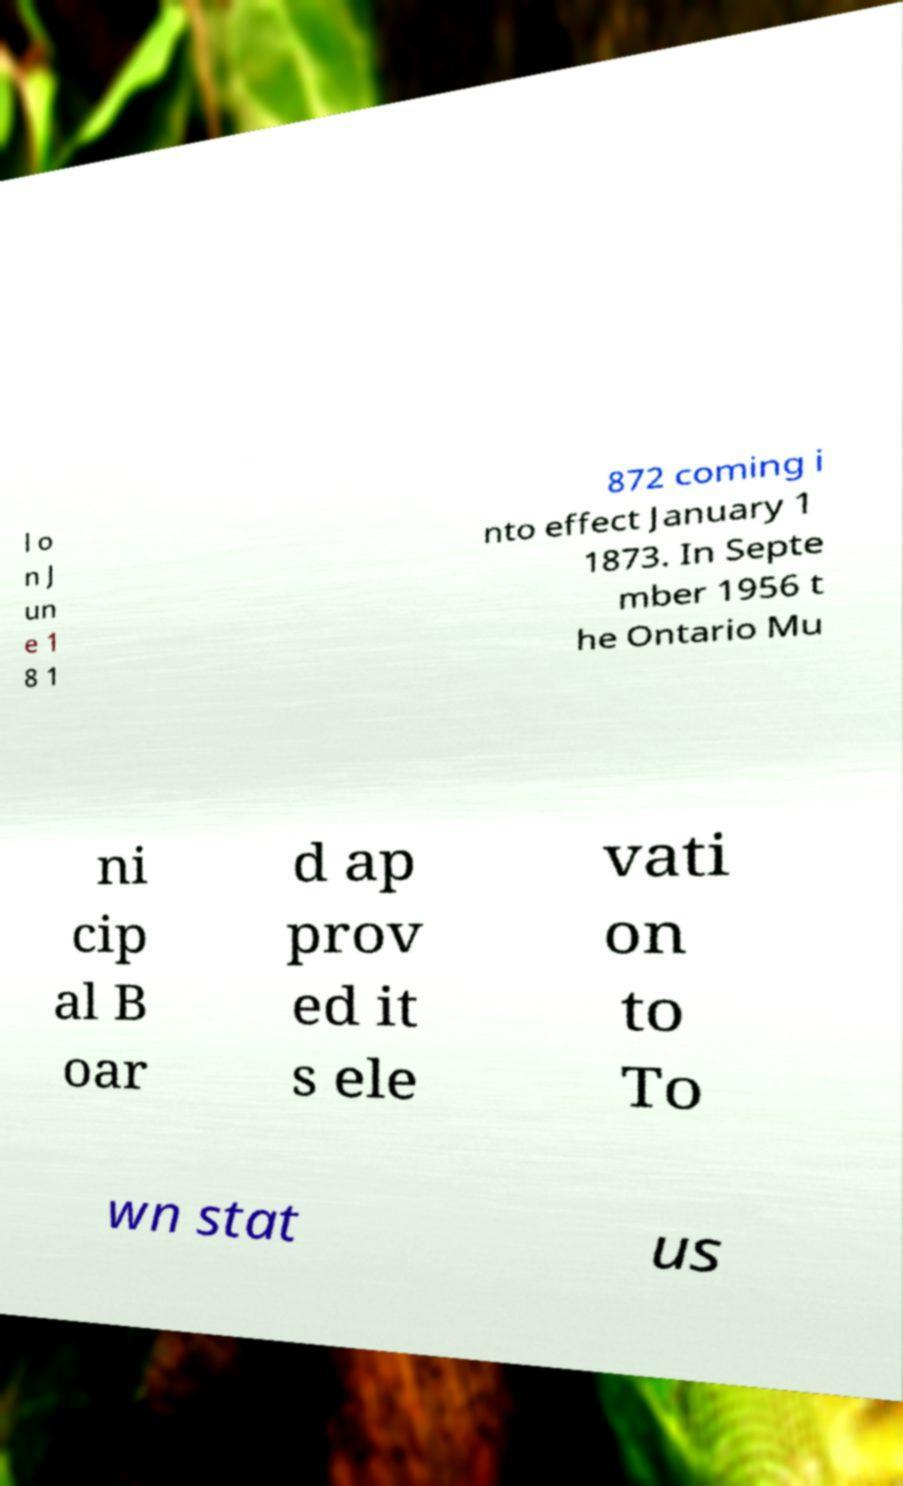Could you assist in decoding the text presented in this image and type it out clearly? l o n J un e 1 8 1 872 coming i nto effect January 1 1873. In Septe mber 1956 t he Ontario Mu ni cip al B oar d ap prov ed it s ele vati on to To wn stat us 